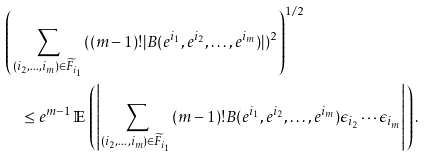<formula> <loc_0><loc_0><loc_500><loc_500>& \left ( \sum _ { ( i _ { 2 } , \dots , i _ { m } ) \in \widetilde { F } _ { i _ { 1 } } } ( ( m - 1 ) ! | B ( e ^ { i _ { 1 } } , e ^ { i _ { 2 } } , \dots , e ^ { i _ { m } } ) | ) ^ { 2 } \right ) ^ { 1 / 2 } \\ & \quad \leq e ^ { m - 1 } \, \mathbb { E } \, \left ( \left | \sum _ { ( i _ { 2 } , \dots , i _ { m } ) \in \widetilde { F } _ { i _ { 1 } } } ( m - 1 ) ! B ( e ^ { i _ { 1 } } , e ^ { i _ { 2 } } , \dots , e ^ { i _ { m } } ) \epsilon _ { i _ { 2 } } \cdots \epsilon _ { i _ { m } } \right | \right ) .</formula> 